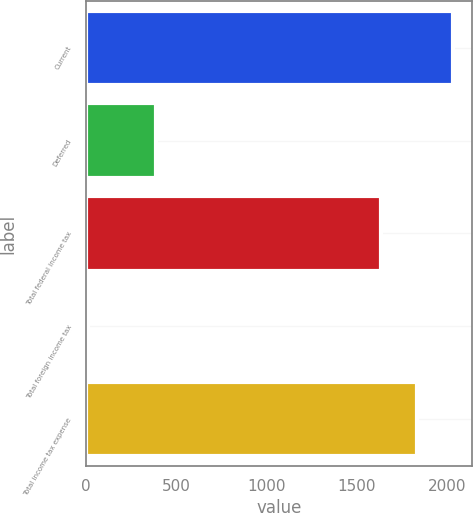<chart> <loc_0><loc_0><loc_500><loc_500><bar_chart><fcel>Current<fcel>Deferred<fcel>Total federal income tax<fcel>Total foreign income tax<fcel>Total income tax expense<nl><fcel>2034.8<fcel>387<fcel>1633<fcel>11<fcel>1833.9<nl></chart> 